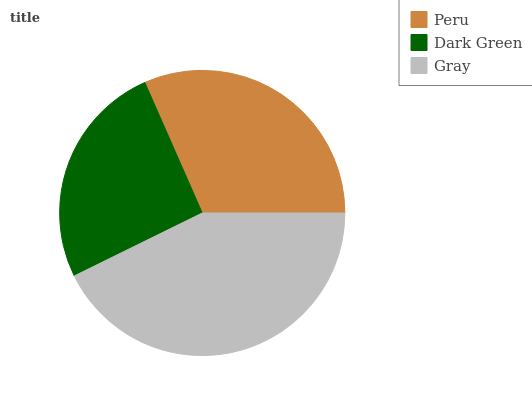Is Dark Green the minimum?
Answer yes or no. Yes. Is Gray the maximum?
Answer yes or no. Yes. Is Gray the minimum?
Answer yes or no. No. Is Dark Green the maximum?
Answer yes or no. No. Is Gray greater than Dark Green?
Answer yes or no. Yes. Is Dark Green less than Gray?
Answer yes or no. Yes. Is Dark Green greater than Gray?
Answer yes or no. No. Is Gray less than Dark Green?
Answer yes or no. No. Is Peru the high median?
Answer yes or no. Yes. Is Peru the low median?
Answer yes or no. Yes. Is Dark Green the high median?
Answer yes or no. No. Is Gray the low median?
Answer yes or no. No. 